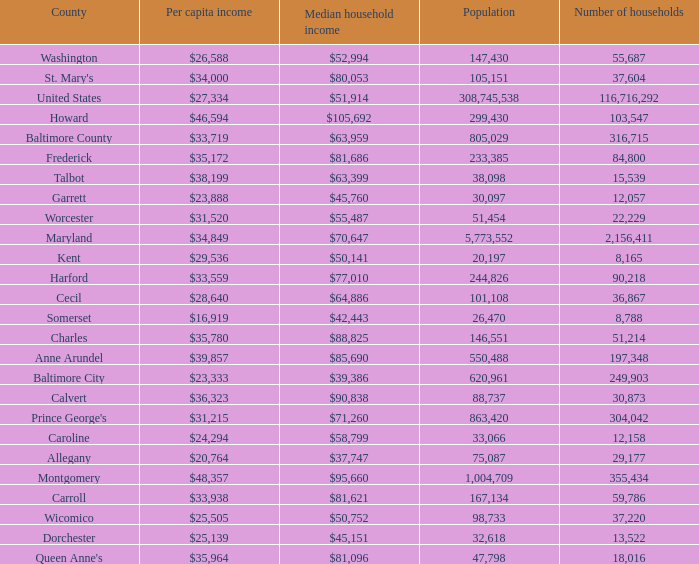What is the per capital income for Charles county? $35,780. Would you be able to parse every entry in this table? {'header': ['County', 'Per capita income', 'Median household income', 'Population', 'Number of households'], 'rows': [['Washington', '$26,588', '$52,994', '147,430', '55,687'], ["St. Mary's", '$34,000', '$80,053', '105,151', '37,604'], ['United States', '$27,334', '$51,914', '308,745,538', '116,716,292'], ['Howard', '$46,594', '$105,692', '299,430', '103,547'], ['Baltimore County', '$33,719', '$63,959', '805,029', '316,715'], ['Frederick', '$35,172', '$81,686', '233,385', '84,800'], ['Talbot', '$38,199', '$63,399', '38,098', '15,539'], ['Garrett', '$23,888', '$45,760', '30,097', '12,057'], ['Worcester', '$31,520', '$55,487', '51,454', '22,229'], ['Maryland', '$34,849', '$70,647', '5,773,552', '2,156,411'], ['Kent', '$29,536', '$50,141', '20,197', '8,165'], ['Harford', '$33,559', '$77,010', '244,826', '90,218'], ['Cecil', '$28,640', '$64,886', '101,108', '36,867'], ['Somerset', '$16,919', '$42,443', '26,470', '8,788'], ['Charles', '$35,780', '$88,825', '146,551', '51,214'], ['Anne Arundel', '$39,857', '$85,690', '550,488', '197,348'], ['Baltimore City', '$23,333', '$39,386', '620,961', '249,903'], ['Calvert', '$36,323', '$90,838', '88,737', '30,873'], ["Prince George's", '$31,215', '$71,260', '863,420', '304,042'], ['Caroline', '$24,294', '$58,799', '33,066', '12,158'], ['Allegany', '$20,764', '$37,747', '75,087', '29,177'], ['Montgomery', '$48,357', '$95,660', '1,004,709', '355,434'], ['Carroll', '$33,938', '$81,621', '167,134', '59,786'], ['Wicomico', '$25,505', '$50,752', '98,733', '37,220'], ['Dorchester', '$25,139', '$45,151', '32,618', '13,522'], ["Queen Anne's", '$35,964', '$81,096', '47,798', '18,016']]} 